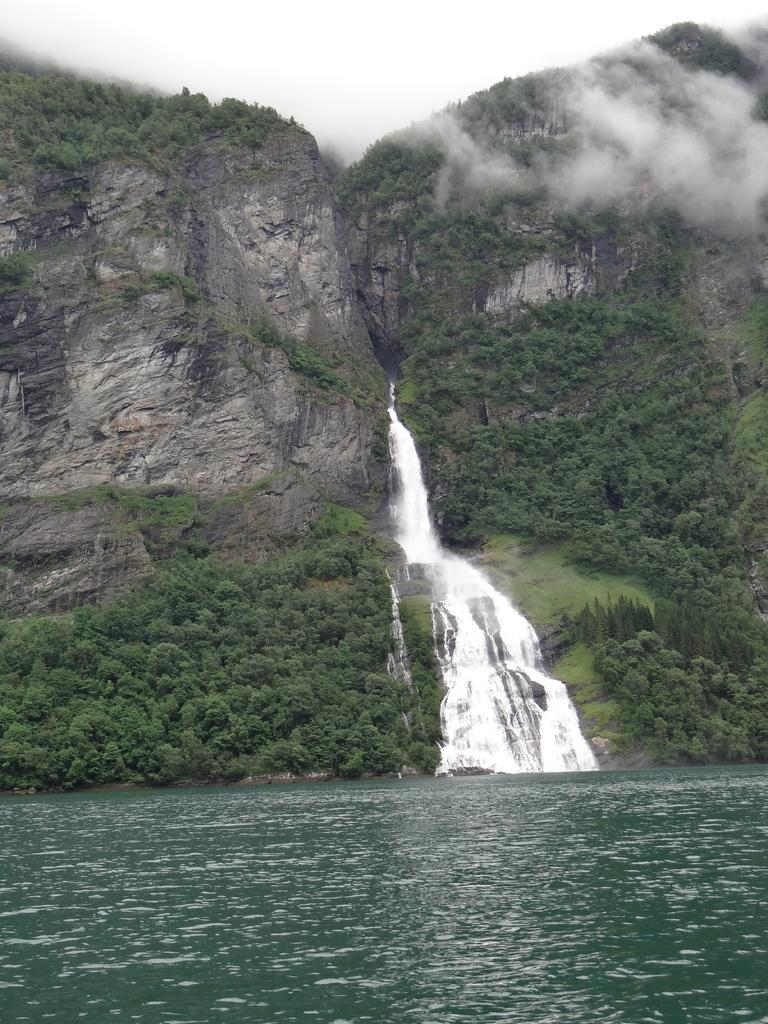What natural feature is the main subject of the image? There is a waterfall in the image. What is the secondary feature visible in the image? There is smoke visible in the image. What body of water is present in the image? There is a river in the image. What type of vegetation can be seen in the image? Trees, bushes, and plants are present in the image. What is the terrain like in the image? Grass is visible on the mountains. What is visible at the top of the image? The sky is visible at the top of the image. How many hens are visible on the waterfall in the image? There are no hens present in the image; it features a waterfall, smoke, a river, trees, bushes, plants, grass, and the sky. 